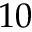<formula> <loc_0><loc_0><loc_500><loc_500>1 0</formula> 